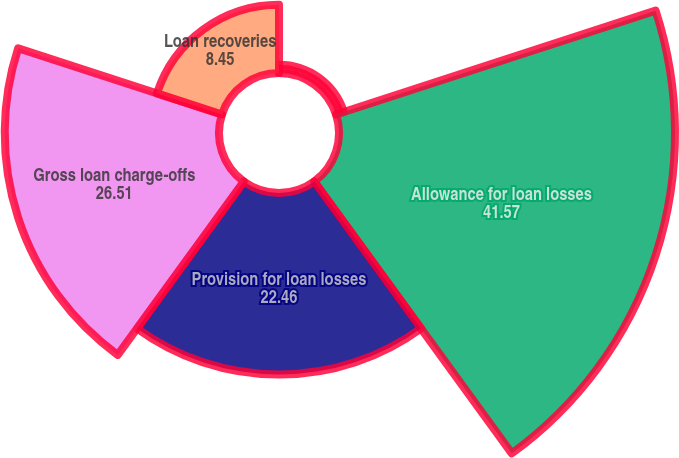Convert chart to OTSL. <chart><loc_0><loc_0><loc_500><loc_500><pie_chart><fcel>(Dollars in thousands except<fcel>Allowance for loan losses<fcel>Provision for loan losses<fcel>Gross loan charge-offs<fcel>Loan recoveries<nl><fcel>1.01%<fcel>41.57%<fcel>22.46%<fcel>26.51%<fcel>8.45%<nl></chart> 